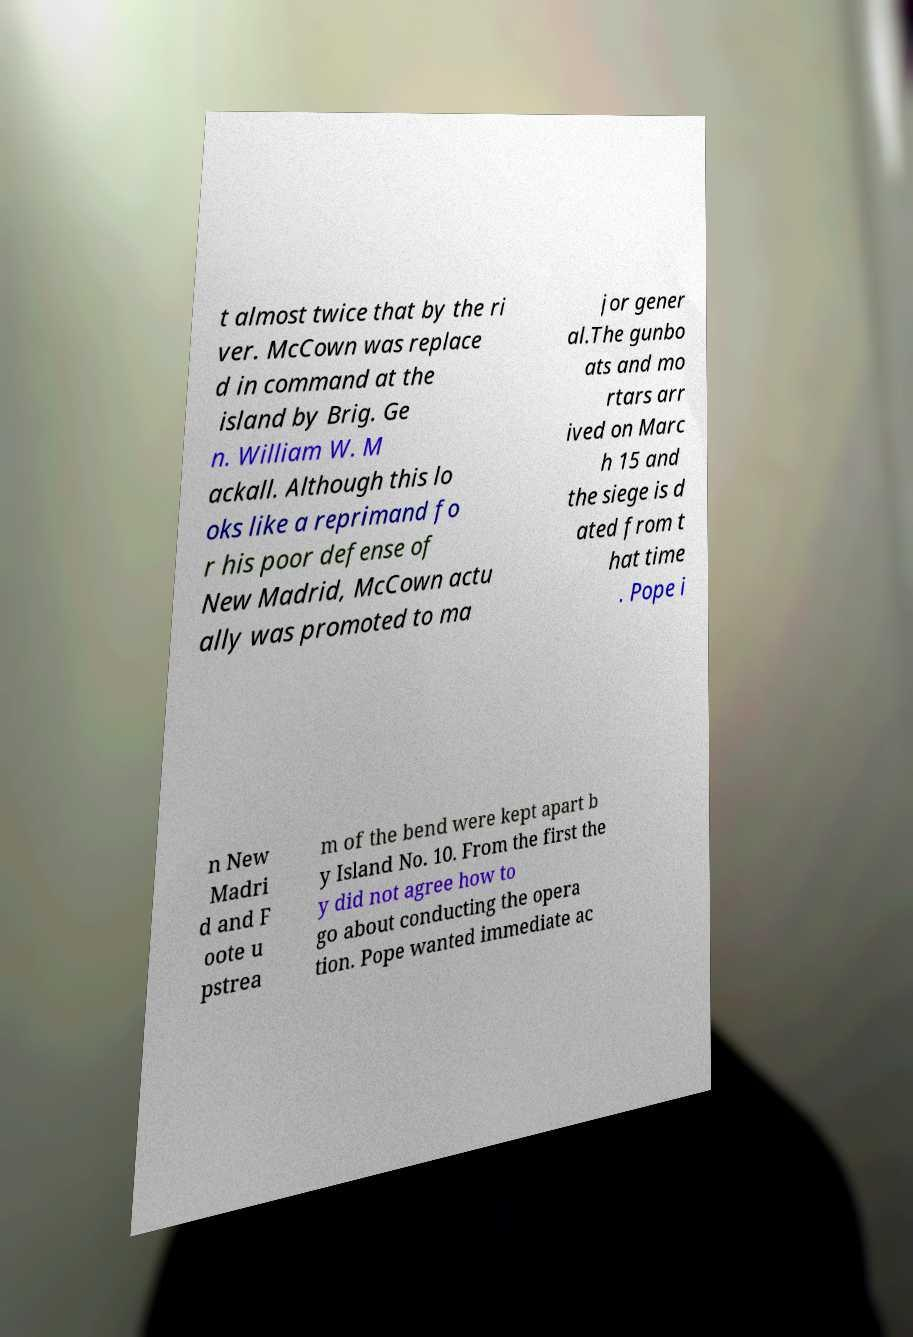Could you assist in decoding the text presented in this image and type it out clearly? t almost twice that by the ri ver. McCown was replace d in command at the island by Brig. Ge n. William W. M ackall. Although this lo oks like a reprimand fo r his poor defense of New Madrid, McCown actu ally was promoted to ma jor gener al.The gunbo ats and mo rtars arr ived on Marc h 15 and the siege is d ated from t hat time . Pope i n New Madri d and F oote u pstrea m of the bend were kept apart b y Island No. 10. From the first the y did not agree how to go about conducting the opera tion. Pope wanted immediate ac 